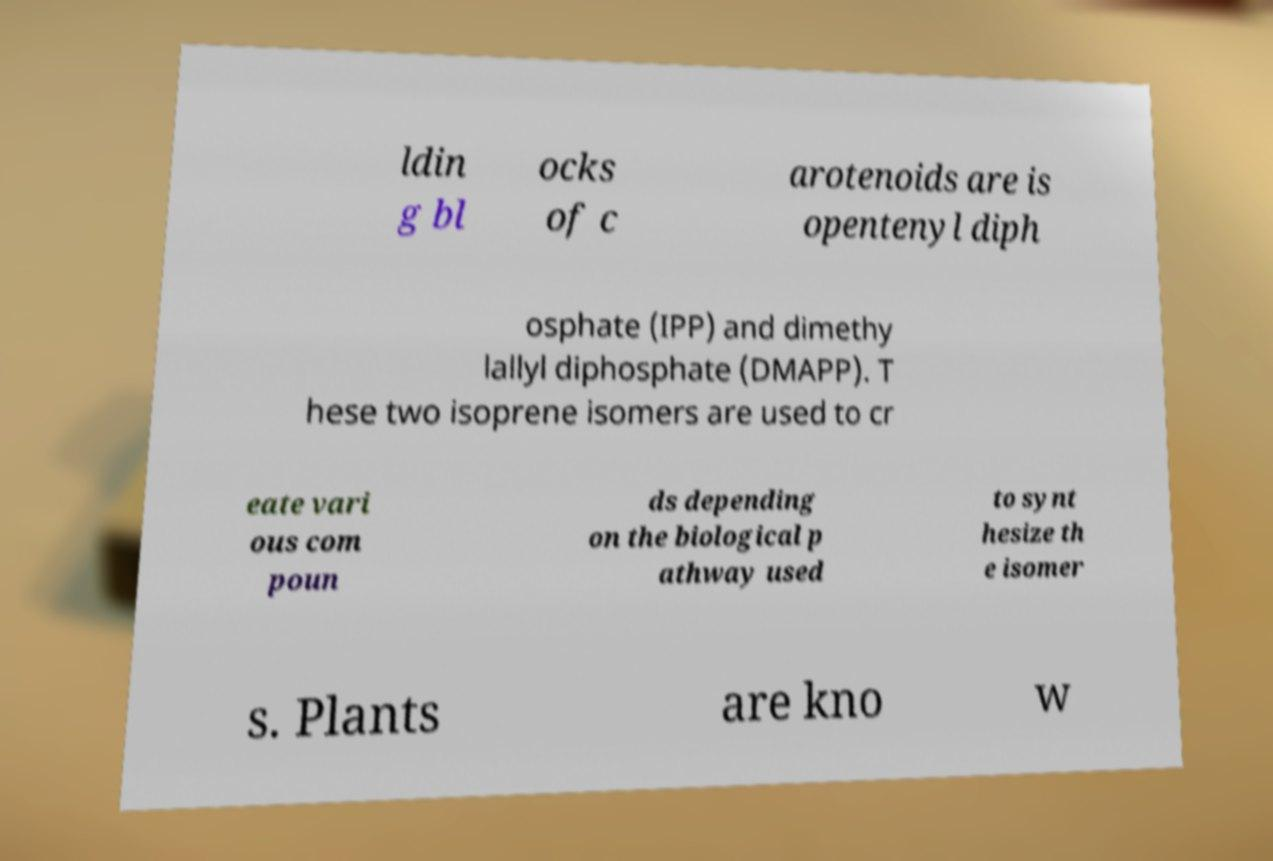Could you extract and type out the text from this image? ldin g bl ocks of c arotenoids are is opentenyl diph osphate (IPP) and dimethy lallyl diphosphate (DMAPP). T hese two isoprene isomers are used to cr eate vari ous com poun ds depending on the biological p athway used to synt hesize th e isomer s. Plants are kno w 